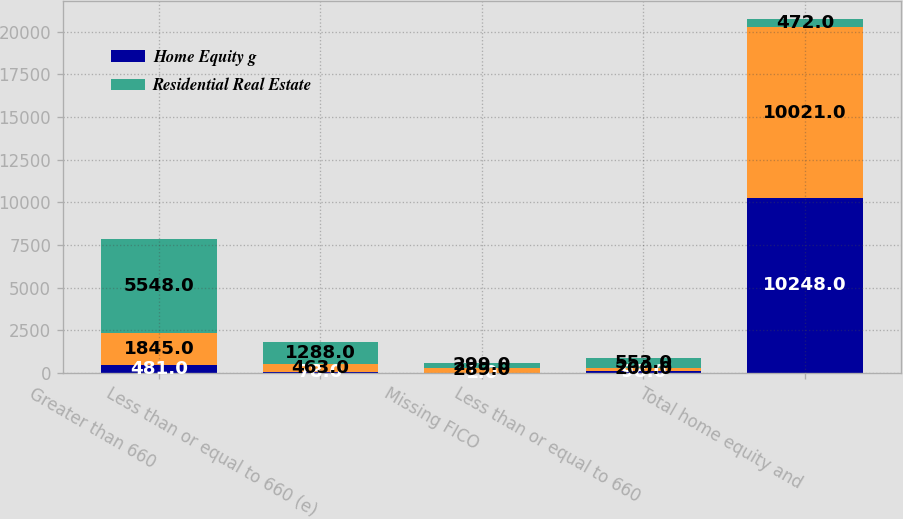Convert chart. <chart><loc_0><loc_0><loc_500><loc_500><stacked_bar_chart><ecel><fcel>Greater than 660<fcel>Less than or equal to 660 (e)<fcel>Missing FICO<fcel>Less than or equal to 660<fcel>Total home equity and<nl><fcel>Home Equity g<fcel>481<fcel>78<fcel>1<fcel>98<fcel>10248<nl><fcel>nan<fcel>1845<fcel>463<fcel>289<fcel>200<fcel>10021<nl><fcel>Residential Real Estate<fcel>5548<fcel>1288<fcel>299<fcel>553<fcel>472<nl></chart> 